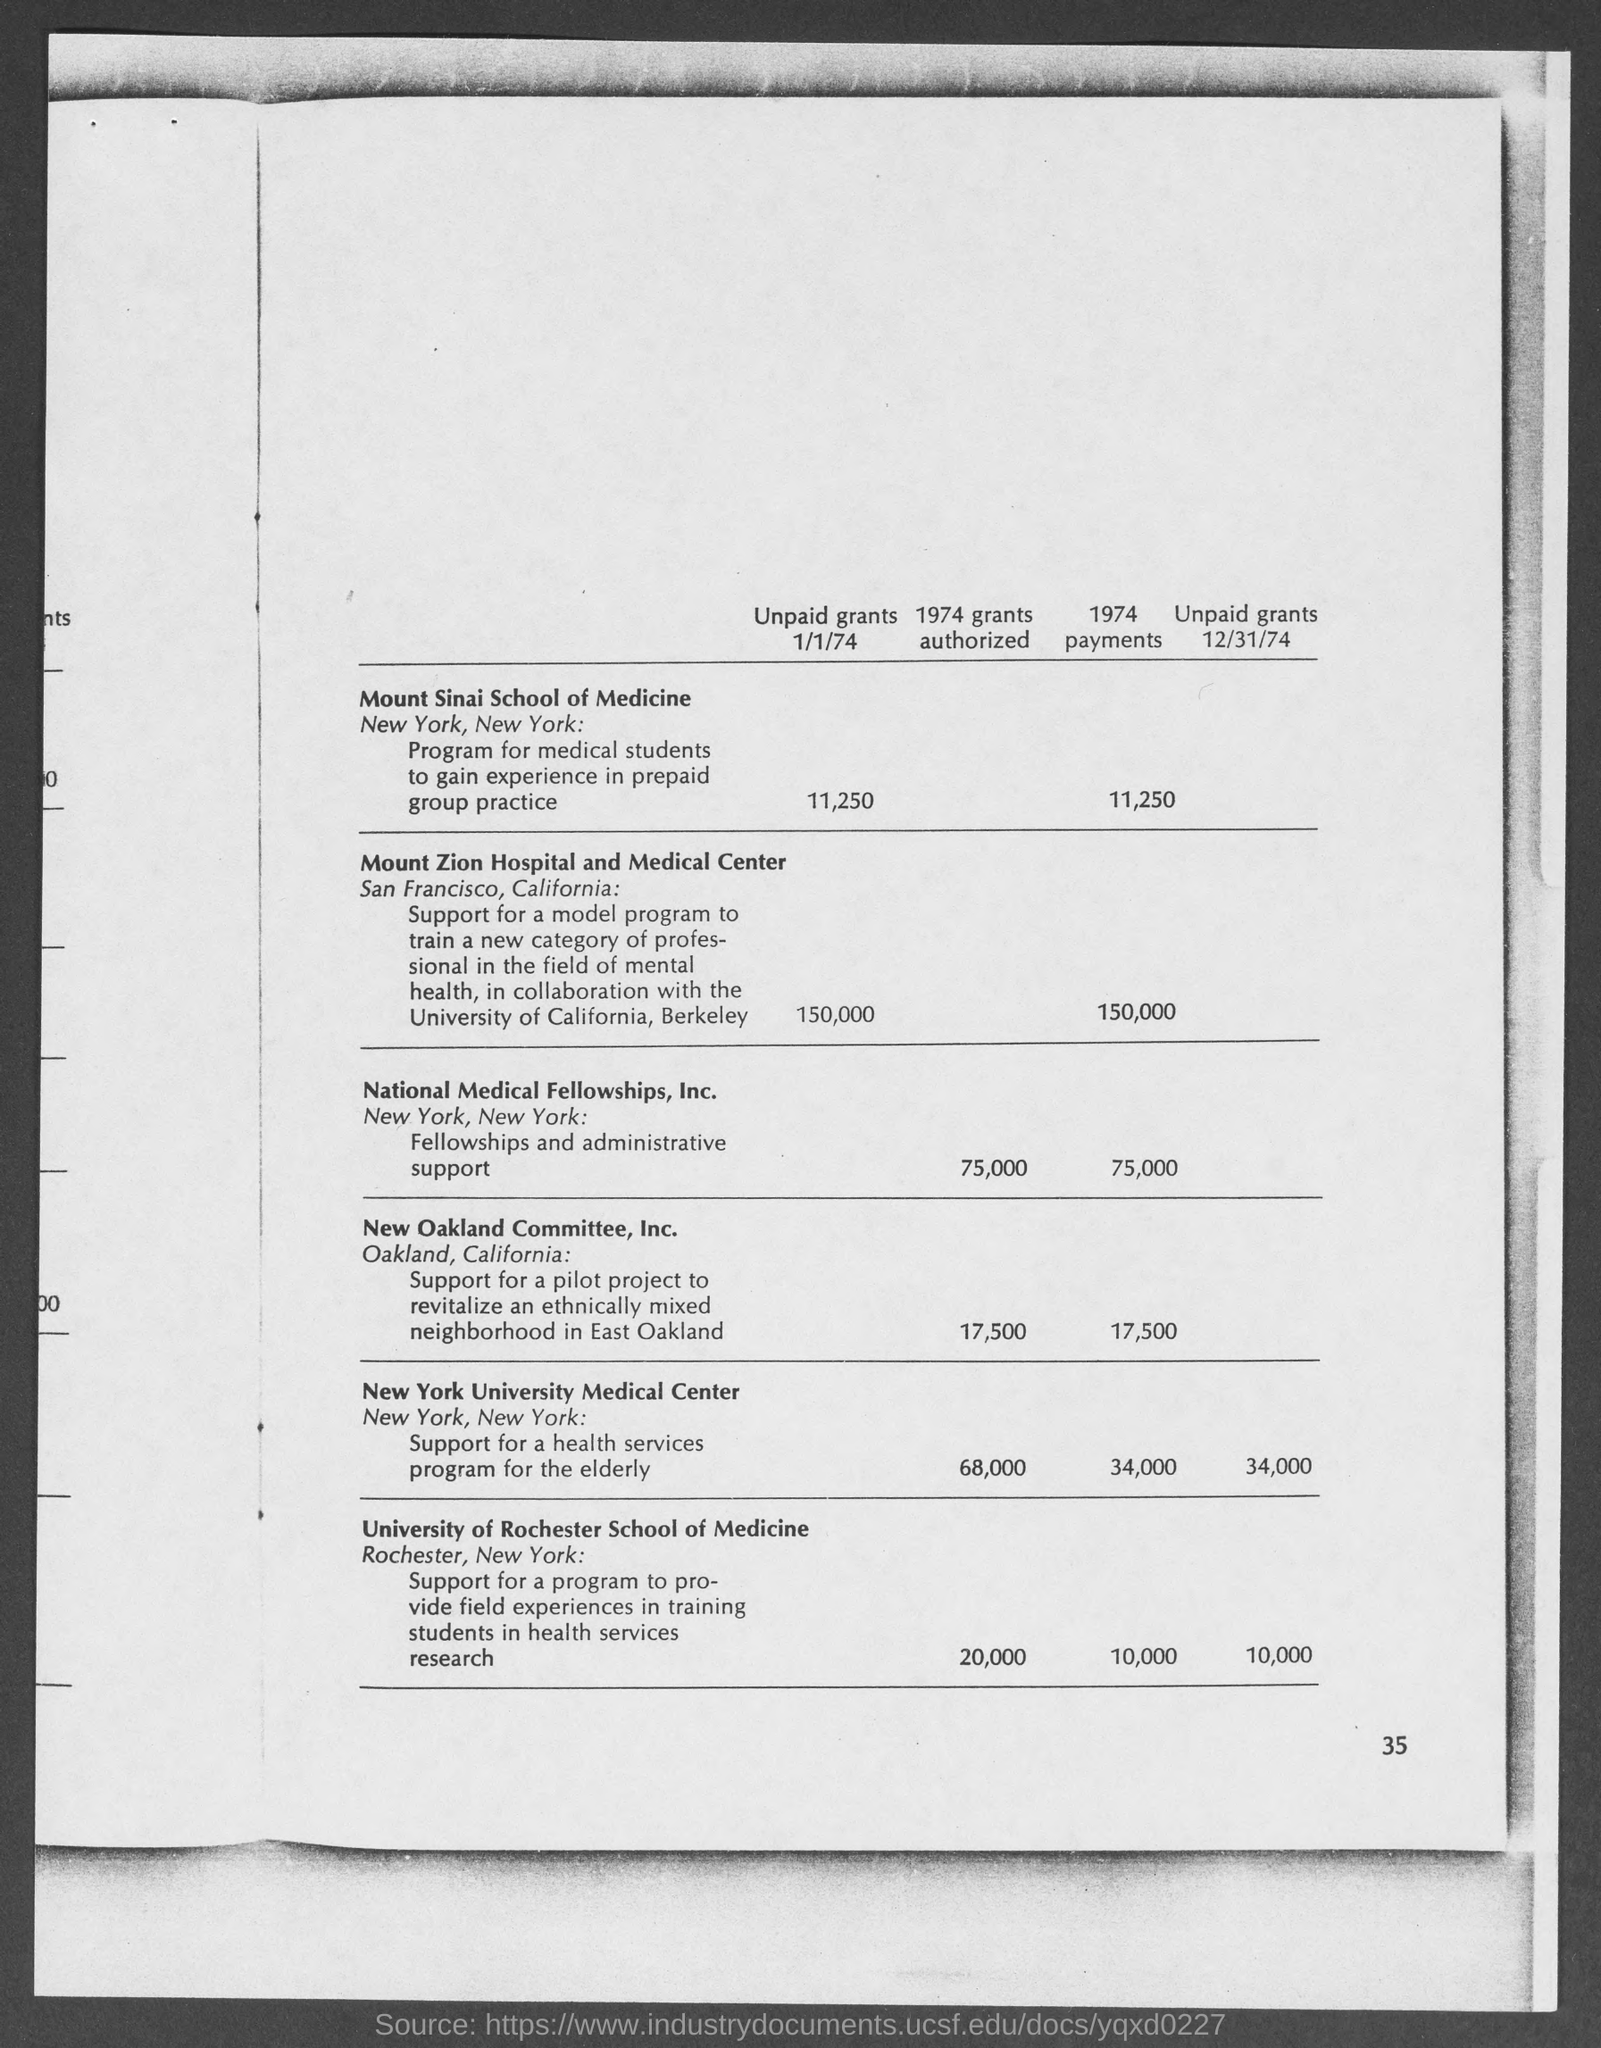Identify some key points in this picture. On January 1st, 1974, the unpaid grants of Mount Sinai School of Medicine were valued at $11,250. 